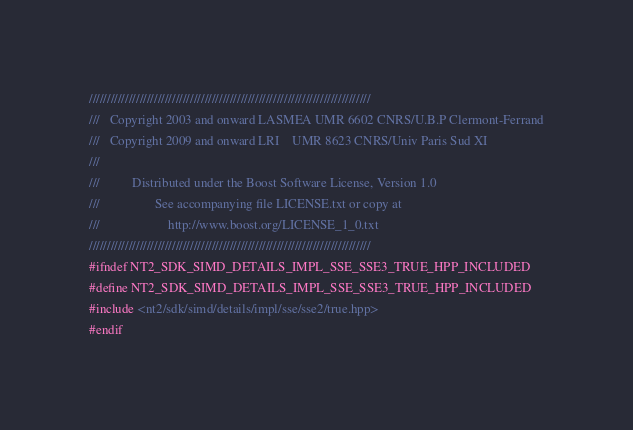Convert code to text. <code><loc_0><loc_0><loc_500><loc_500><_C++_>//////////////////////////////////////////////////////////////////////////////
///   Copyright 2003 and onward LASMEA UMR 6602 CNRS/U.B.P Clermont-Ferrand
///   Copyright 2009 and onward LRI    UMR 8623 CNRS/Univ Paris Sud XI
///
///          Distributed under the Boost Software License, Version 1.0
///                 See accompanying file LICENSE.txt or copy at
///                     http://www.boost.org/LICENSE_1_0.txt
//////////////////////////////////////////////////////////////////////////////
#ifndef NT2_SDK_SIMD_DETAILS_IMPL_SSE_SSE3_TRUE_HPP_INCLUDED
#define NT2_SDK_SIMD_DETAILS_IMPL_SSE_SSE3_TRUE_HPP_INCLUDED
#include <nt2/sdk/simd/details/impl/sse/sse2/true.hpp>
#endif
</code> 